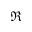Convert formula to latex. <formula><loc_0><loc_0><loc_500><loc_500>\Re</formula> 